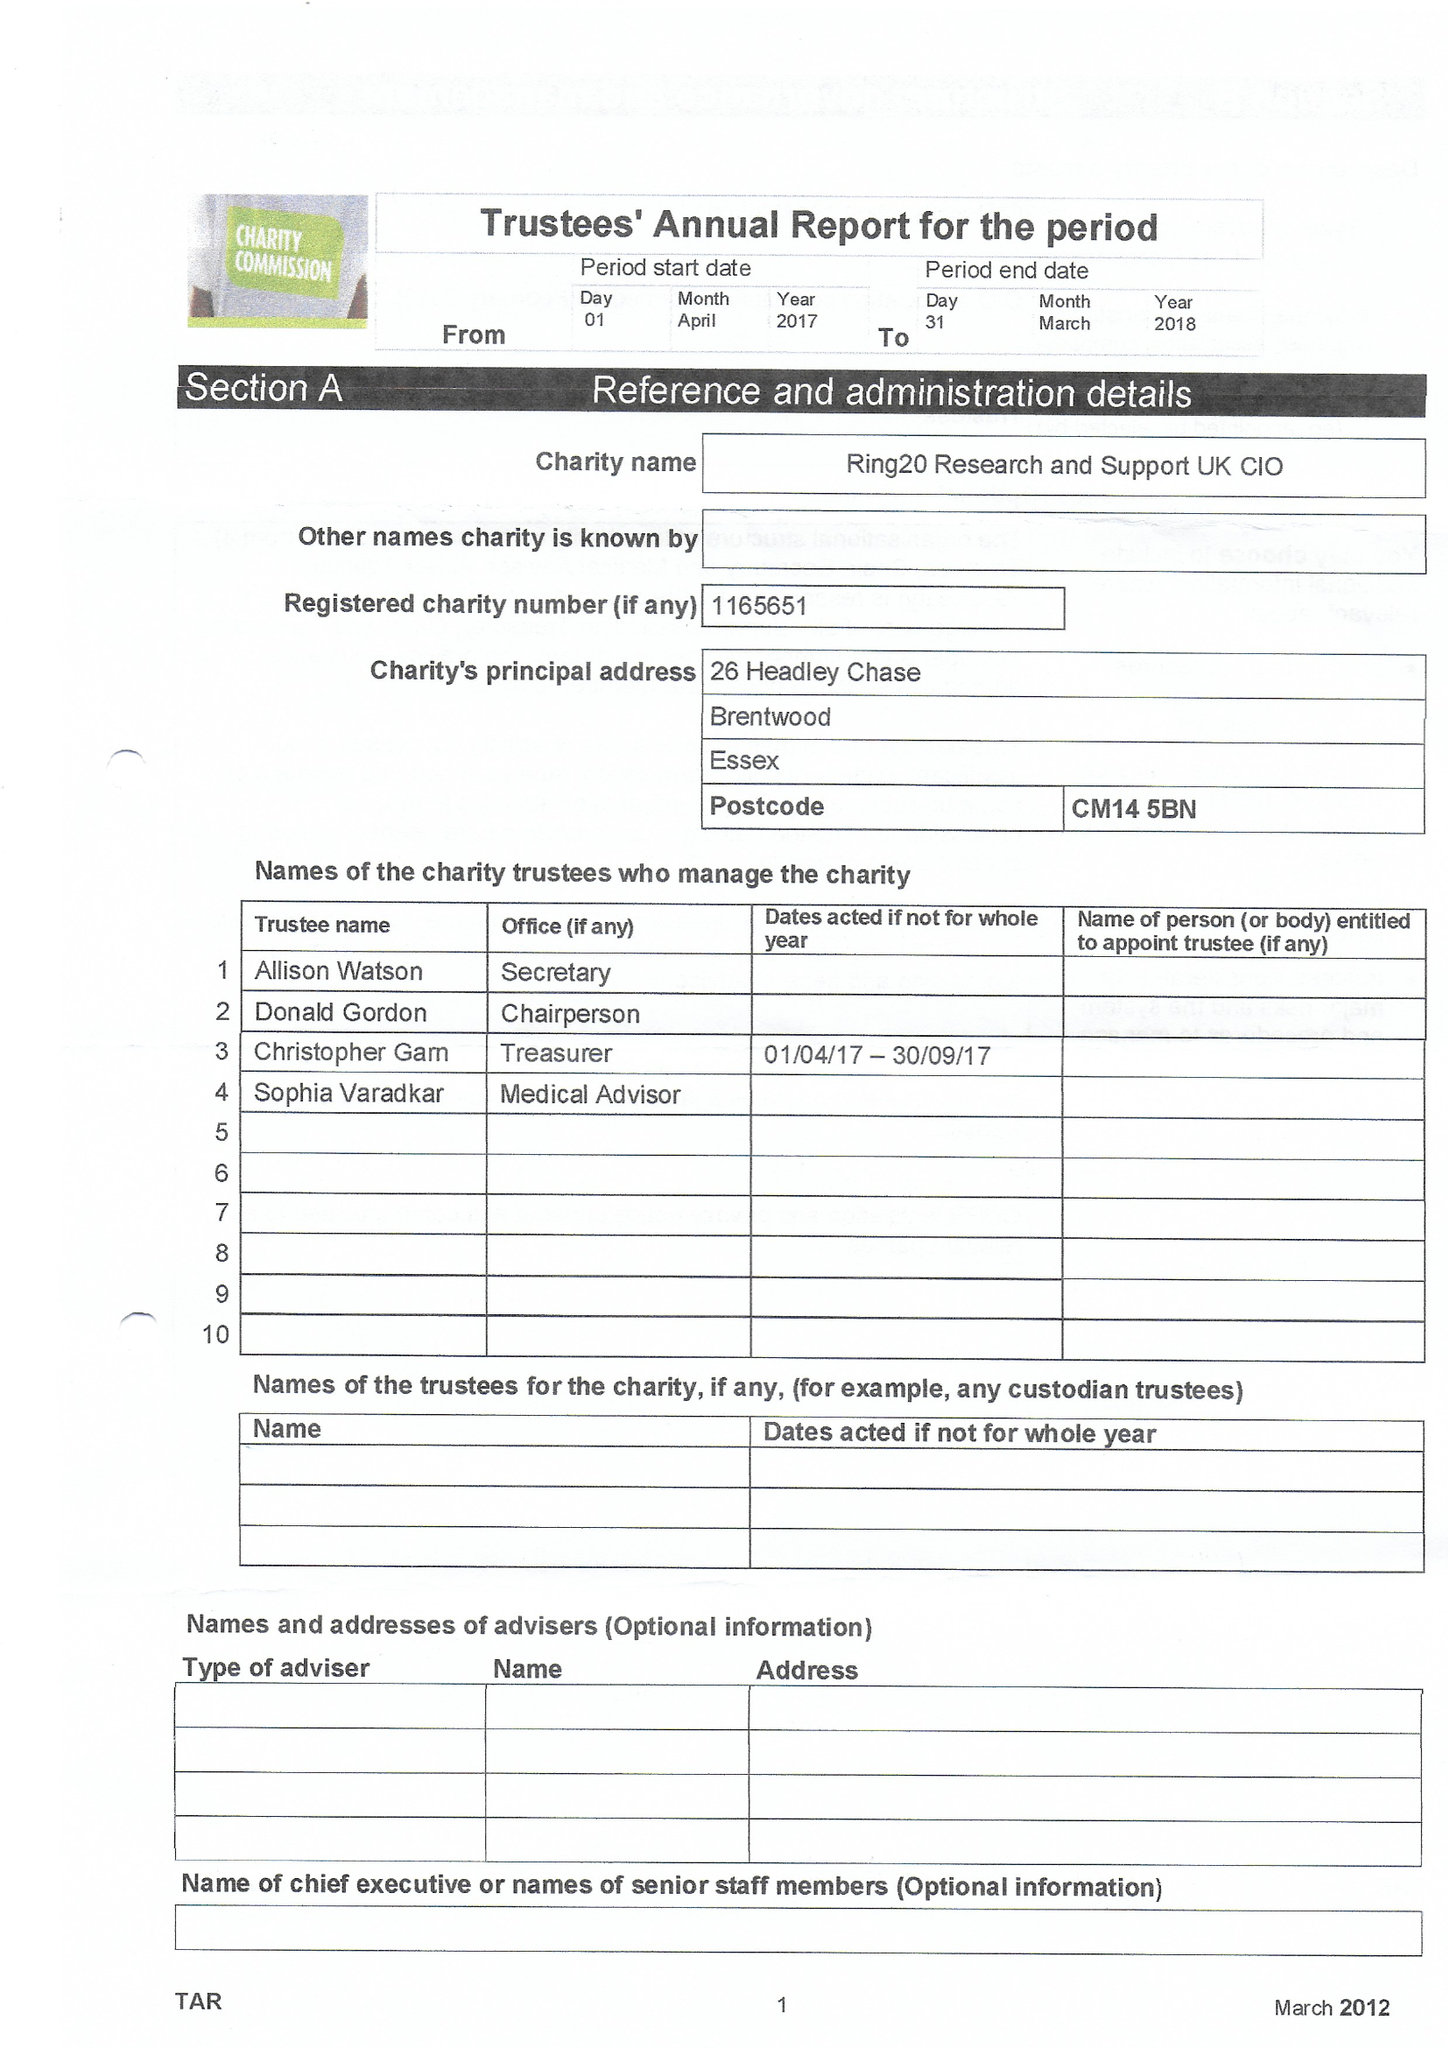What is the value for the income_annually_in_british_pounds?
Answer the question using a single word or phrase. None 